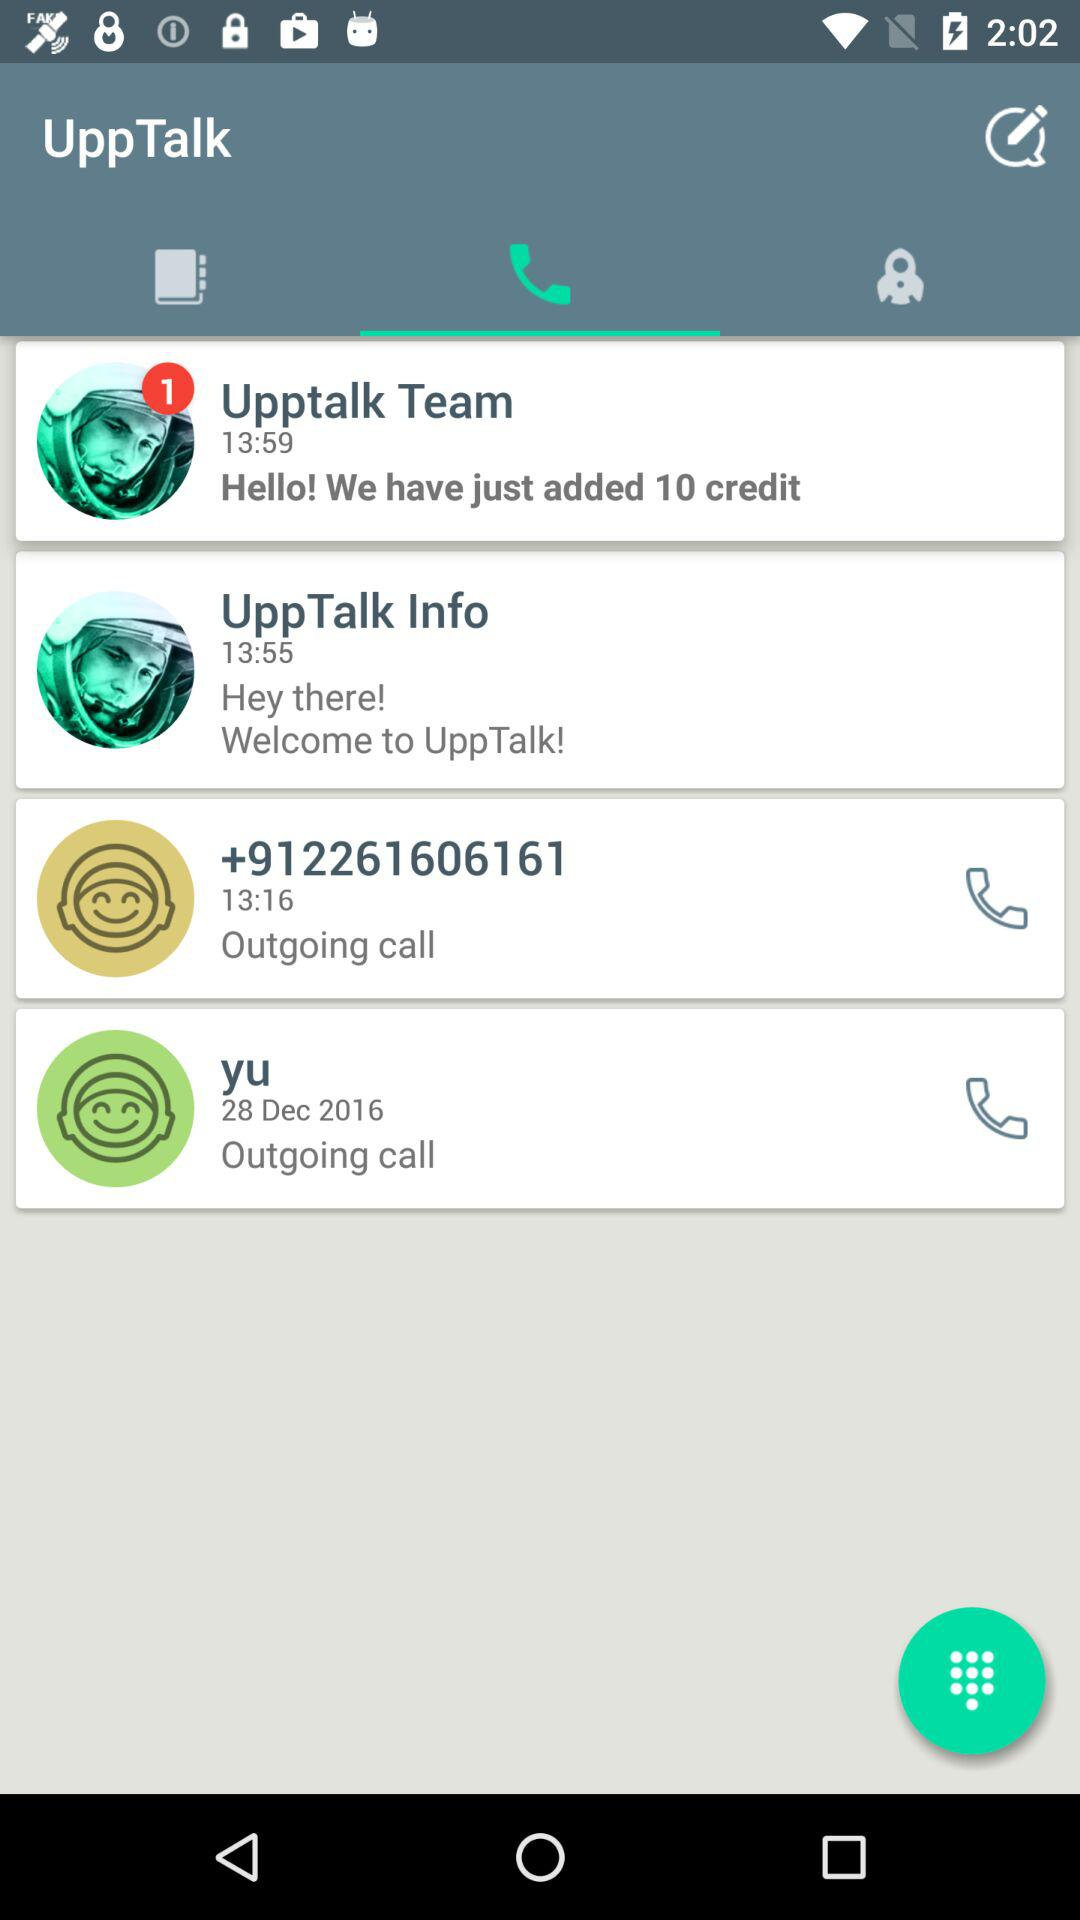Which tab is currently selected? The currently selected tab is "Recent Calls". 